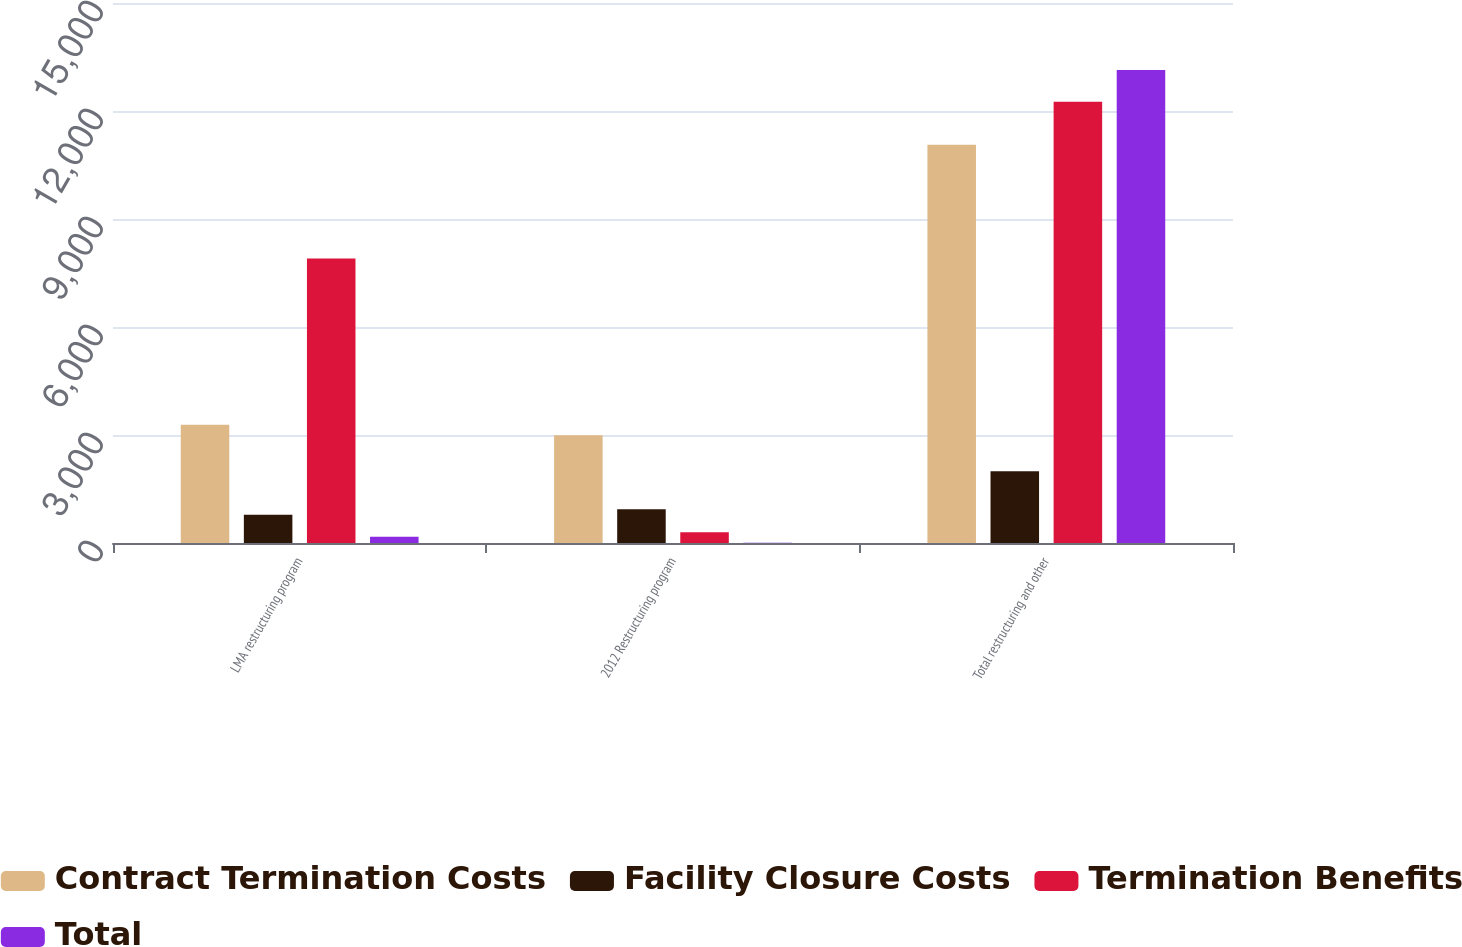Convert chart to OTSL. <chart><loc_0><loc_0><loc_500><loc_500><stacked_bar_chart><ecel><fcel>LMA restructuring program<fcel>2012 Restructuring program<fcel>Total restructuring and other<nl><fcel>Contract Termination Costs<fcel>3282<fcel>2993<fcel>11062<nl><fcel>Facility Closure Costs<fcel>788<fcel>935<fcel>1995<nl><fcel>Termination Benefits<fcel>7906<fcel>296<fcel>12256<nl><fcel>Total<fcel>176<fcel>5<fcel>13139<nl></chart> 